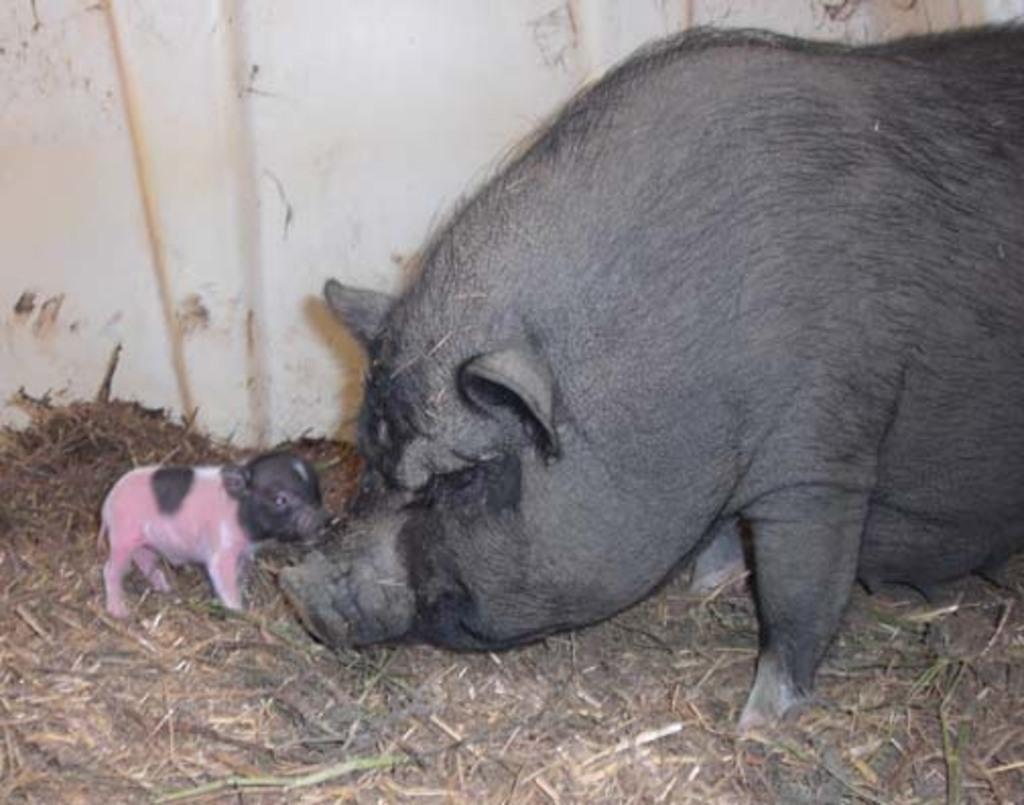What type of animal is in the image? There is a pig in the image. Are there any baby animals in the image? Yes, there is a baby pig in the image. What can be seen in the background of the image? There is a wall in the background of the image. What is present at the bottom of the image? There is some material at the bottom of the image. What type of rice is being harvested by the pig in the image? There is no rice or harvesting activity present in the image; it features a pig and a baby pig. 